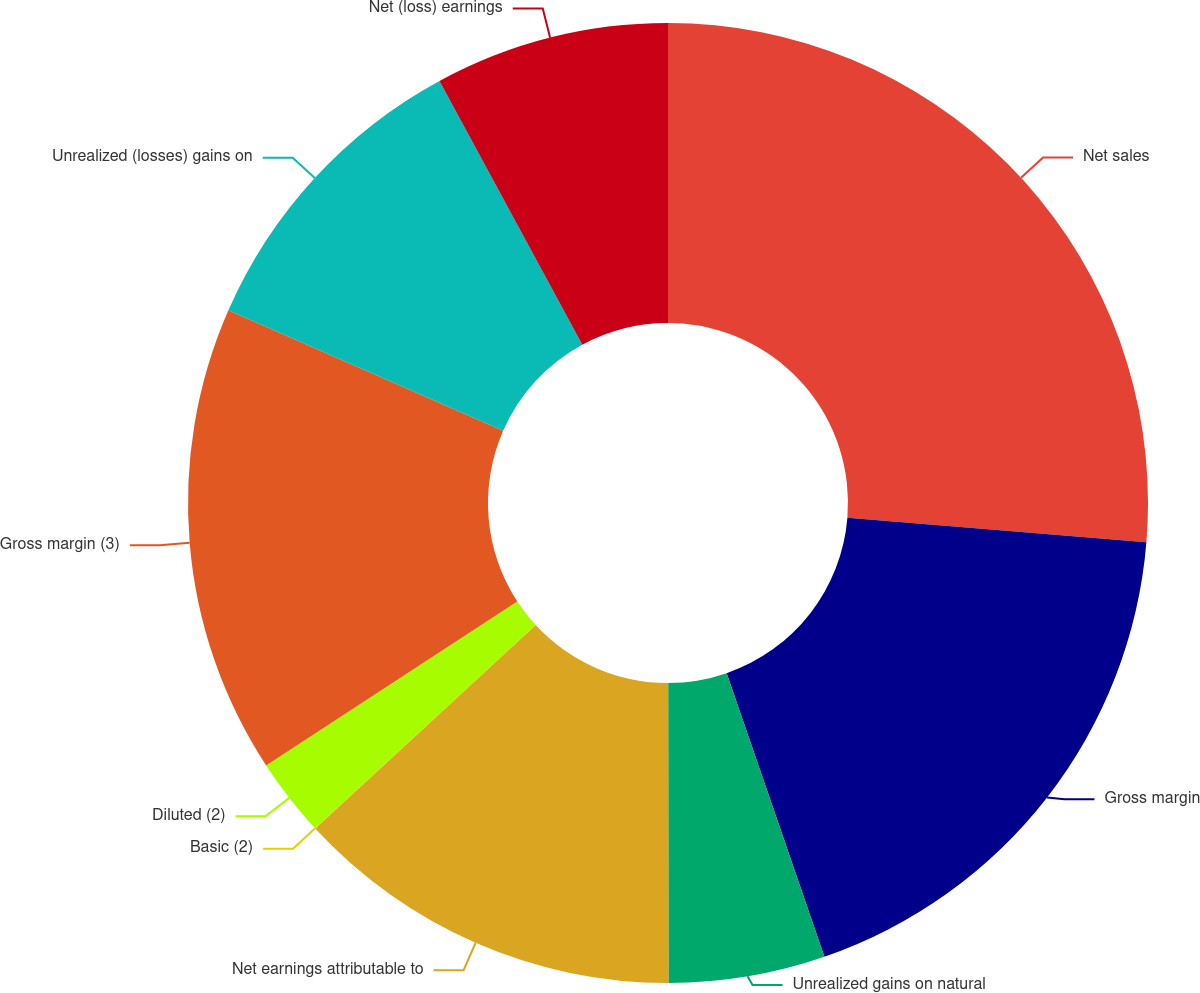Convert chart. <chart><loc_0><loc_0><loc_500><loc_500><pie_chart><fcel>Net sales<fcel>Gross margin<fcel>Unrealized gains on natural<fcel>Net earnings attributable to<fcel>Basic (2)<fcel>Diluted (2)<fcel>Gross margin (3)<fcel>Unrealized (losses) gains on<fcel>Net (loss) earnings<nl><fcel>26.31%<fcel>18.42%<fcel>5.27%<fcel>13.16%<fcel>0.01%<fcel>2.64%<fcel>15.79%<fcel>10.53%<fcel>7.9%<nl></chart> 